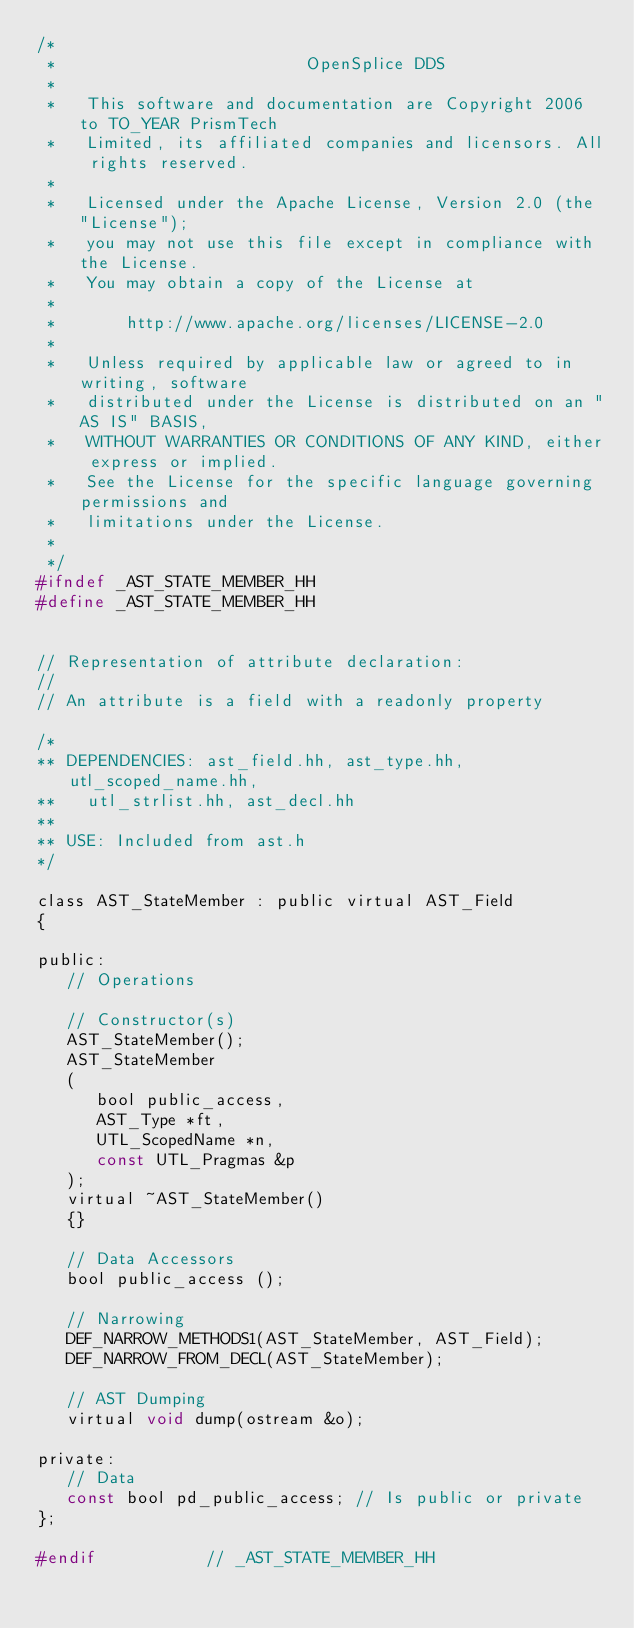Convert code to text. <code><loc_0><loc_0><loc_500><loc_500><_C_>/*
 *                         OpenSplice DDS
 *
 *   This software and documentation are Copyright 2006 to TO_YEAR PrismTech
 *   Limited, its affiliated companies and licensors. All rights reserved.
 *
 *   Licensed under the Apache License, Version 2.0 (the "License");
 *   you may not use this file except in compliance with the License.
 *   You may obtain a copy of the License at
 *
 *       http://www.apache.org/licenses/LICENSE-2.0
 *
 *   Unless required by applicable law or agreed to in writing, software
 *   distributed under the License is distributed on an "AS IS" BASIS,
 *   WITHOUT WARRANTIES OR CONDITIONS OF ANY KIND, either express or implied.
 *   See the License for the specific language governing permissions and
 *   limitations under the License.
 *
 */
#ifndef _AST_STATE_MEMBER_HH
#define _AST_STATE_MEMBER_HH


// Representation of attribute declaration:
//
// An attribute is a field with a readonly property

/*
** DEPENDENCIES: ast_field.hh, ast_type.hh, utl_scoped_name.hh,
**   utl_strlist.hh, ast_decl.hh
**
** USE: Included from ast.h
*/

class AST_StateMember : public virtual AST_Field
{

public:
   // Operations

   // Constructor(s)
   AST_StateMember();
   AST_StateMember
   (
      bool public_access,
      AST_Type *ft,
      UTL_ScopedName *n,
      const UTL_Pragmas &p
   );
   virtual ~AST_StateMember()
   {}

   // Data Accessors
   bool public_access ();

   // Narrowing
   DEF_NARROW_METHODS1(AST_StateMember, AST_Field);
   DEF_NARROW_FROM_DECL(AST_StateMember);

   // AST Dumping
   virtual void dump(ostream &o);

private:
   // Data
   const bool pd_public_access; // Is public or private
};

#endif           // _AST_STATE_MEMBER_HH
</code> 